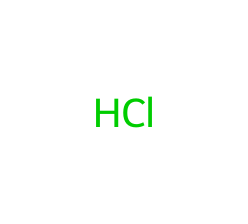What is the molecular formula of this chemical? The SMILES representation indicates one hydrogen atom and one chlorine atom. Therefore, the molecular formula is derived by counting the atoms, which leads to HCl.
Answer: HCl How many atoms are present in this chemical structure? From the SMILES representation, there are one hydrogen atom and one chlorine atom. Adding these together, we get a total of two atoms.
Answer: 2 Is this chemical an acid? Hydrochloric acid is known to have acidic properties, particularly because it can donate a proton (H+) in solution, which is a characteristic of acids.
Answer: Yes What is the pH range for this acid in a solution? Hydrochloric acid is strong and typically has a pH below 1 when concentrated and around 1-3 when diluted in aqueous solutions.
Answer: Below 1 What role does this chemical play in the stomach? Hydrochloric acid aids digestion by creating an acidic environment that activates enzymes like pepsin, which is crucial for protein digestion.
Answer: Digestion What property makes this acid useful in swimming pool cleaners? Hydrochloric acid lowers the pH of water and helps to remove scale and disinfect the pool, making it effective for pool maintenance.
Answer: pH reduction 